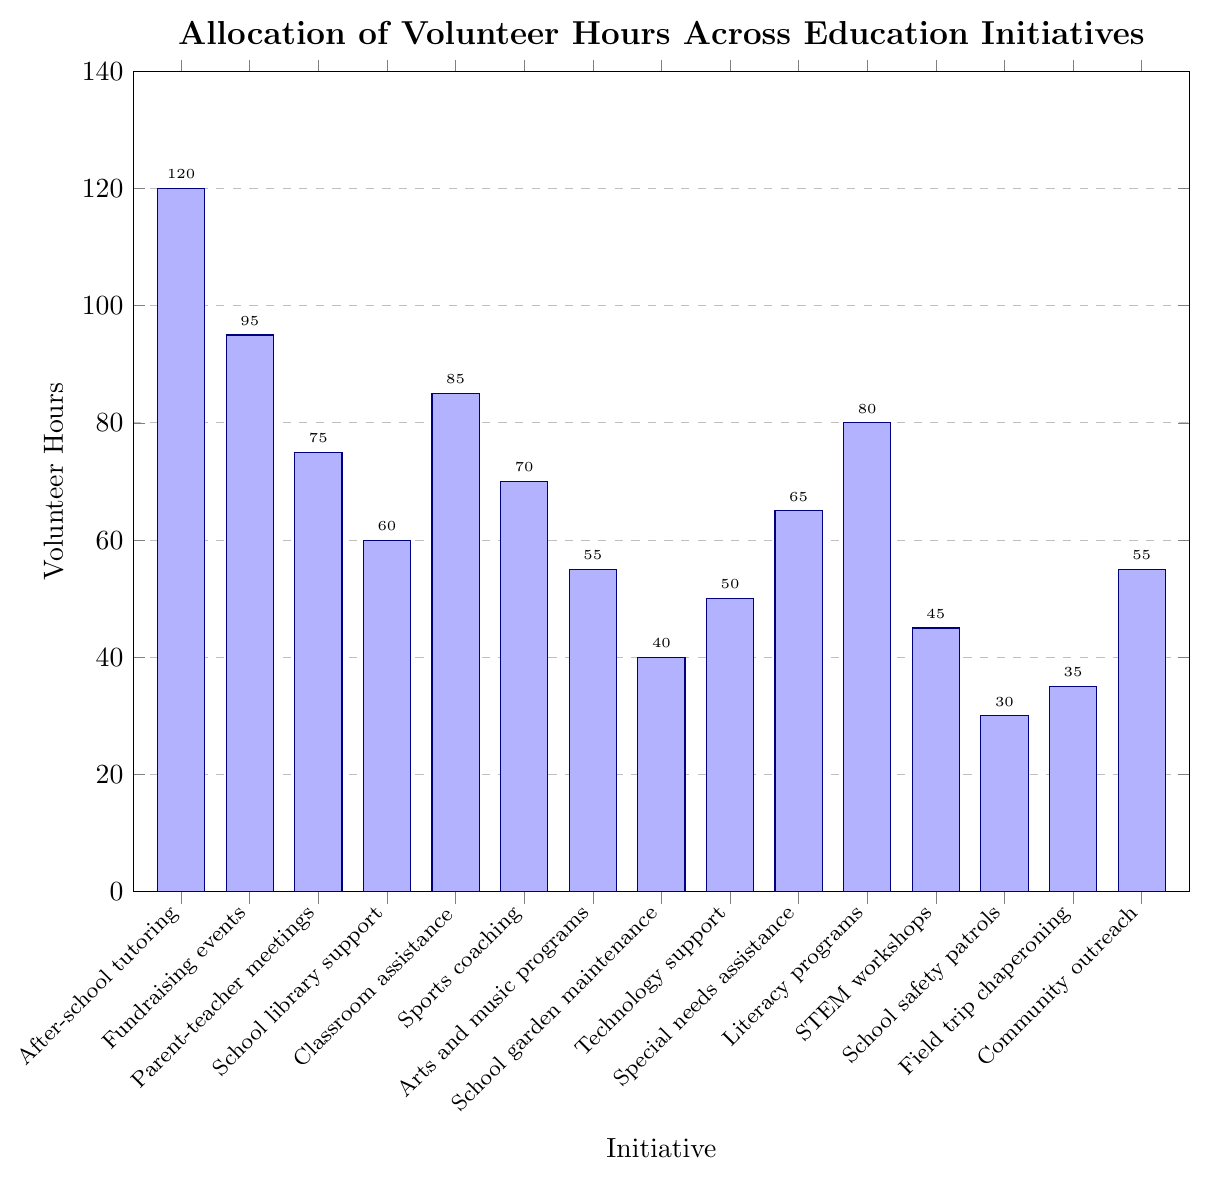Which initiative has the highest allocation of volunteer hours? By looking at the height of the bars, we see that "After-school tutoring" reaches the highest, indicating it has the highest volunteer hours.
Answer: After-school tutoring Which two initiatives have equal volunteer hours? By observing the bars' heights, we see that "Arts and music programs" and "Community outreach" have bars of the same height, showing they have equal volunteer hours.
Answer: Arts and music programs and Community outreach What is the combined volunteer hours for Sports coaching and Literacy programs? By adding the volunteer hours of "Sports coaching" (70) and "Literacy programs" (80), we get 70 + 80 = 150.
Answer: 150 Which initiative has the least volunteer hours, and how many hours is it? By looking at the bars' heights, we see that "School safety patrols" has the shortest bar, indicating the least volunteer hours. The value is 30.
Answer: School safety patrols, 30 How much more volunteer hours does After-school tutoring have compared to STEM workshops? By subtracting the volunteer hours of "STEM workshops" (45) from "After-school tutoring" (120), we get 120 - 45 = 75.
Answer: 75 What is the average volunteer hours across all initiatives? Summing all volunteer hours, we get 120 + 95 + 75 + 60 + 85 + 70 + 55 + 40 + 50 + 65 + 80 + 45 + 30 + 35 + 55 = 960. Dividing by the number of initiatives (15), the average is 960 / 15 = 64.
Answer: 64 Which initiatives have volunteer hours greater than 80? By checking the bars with heights greater than 80, we see that "After-school tutoring" (120) and "Fundraising events" (95) satisfy this condition.
Answer: After-school tutoring and Fundraising events What is the difference in volunteer hours between Classroom assistance and School garden maintenance? Subtracting the volunteer hours of "School garden maintenance" (40) from "Classroom assistance" (85), we get 85 - 40 = 45.
Answer: 45 Which initiative has slightly fewer volunteer hours than Parent-teacher meetings? By comparing the bars, the height just below "Parent-teacher meetings" (75) is "Classroom assistance" with 70 volunteer hours.
Answer: Sports coaching What is the total volunteer hours for initiatives related to arts, music, and literacy (Arts and music programs, Literacy programs)? Adding the volunteer hours for "Arts and music programs" (55) and "Literacy programs" (80), we get 55 + 80 = 135.
Answer: 135 